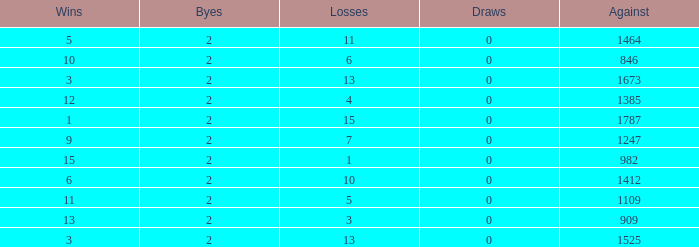What is the average number of Byes when there were less than 0 losses and were against 1247? None. 